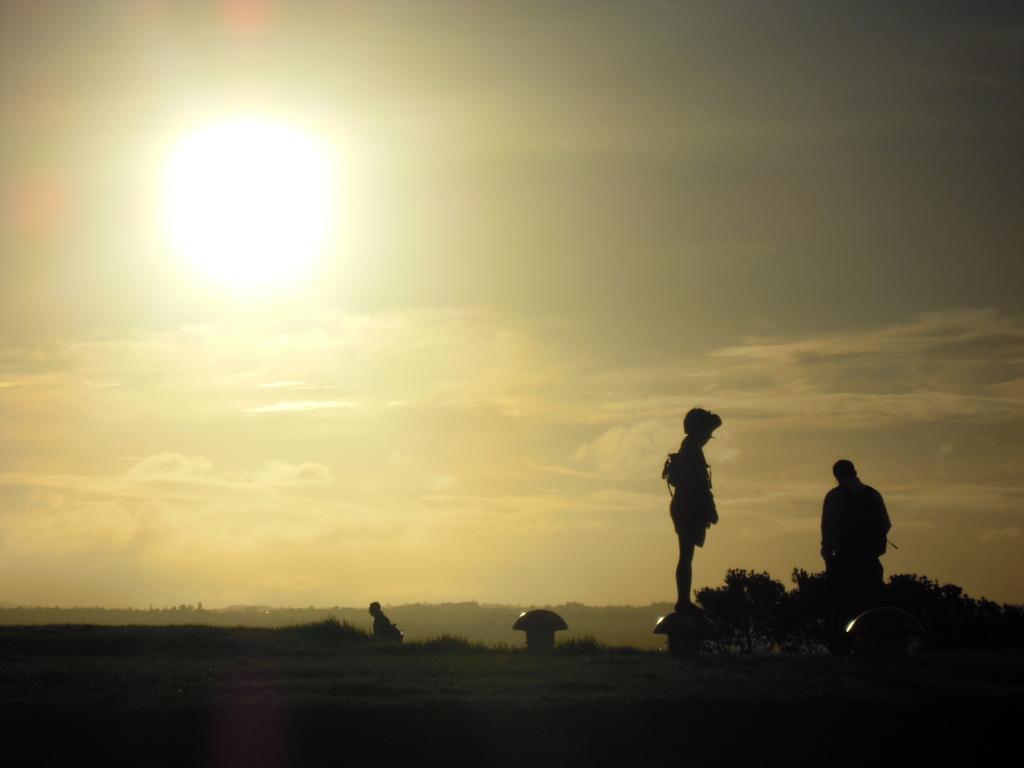Can you describe this image briefly? This image is clicked outside. In this image we can see three persons. At the bottom, there is a ground. In the background, there are clouds in the sky along with the sun. 